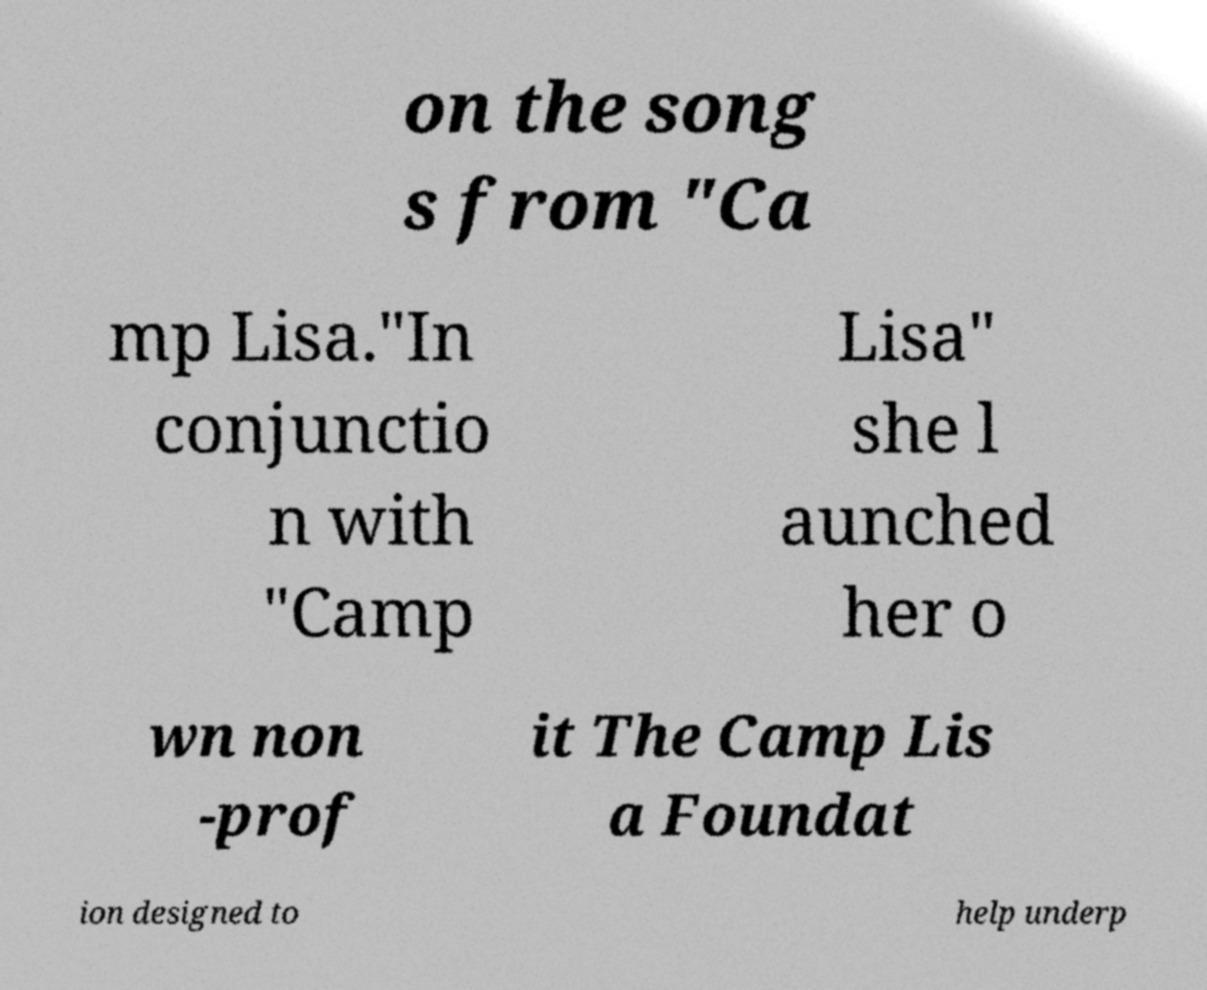Could you assist in decoding the text presented in this image and type it out clearly? on the song s from "Ca mp Lisa."In conjunctio n with "Camp Lisa" she l aunched her o wn non -prof it The Camp Lis a Foundat ion designed to help underp 